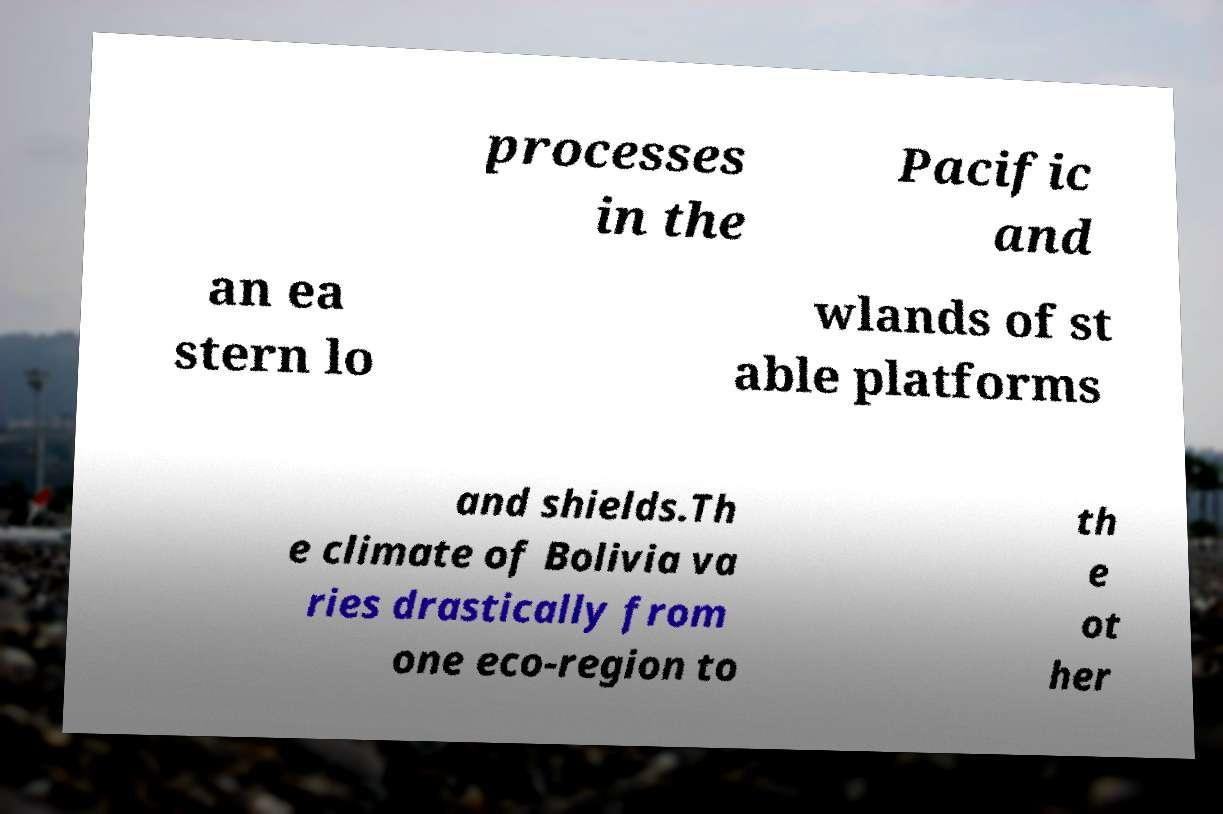I need the written content from this picture converted into text. Can you do that? processes in the Pacific and an ea stern lo wlands of st able platforms and shields.Th e climate of Bolivia va ries drastically from one eco-region to th e ot her 